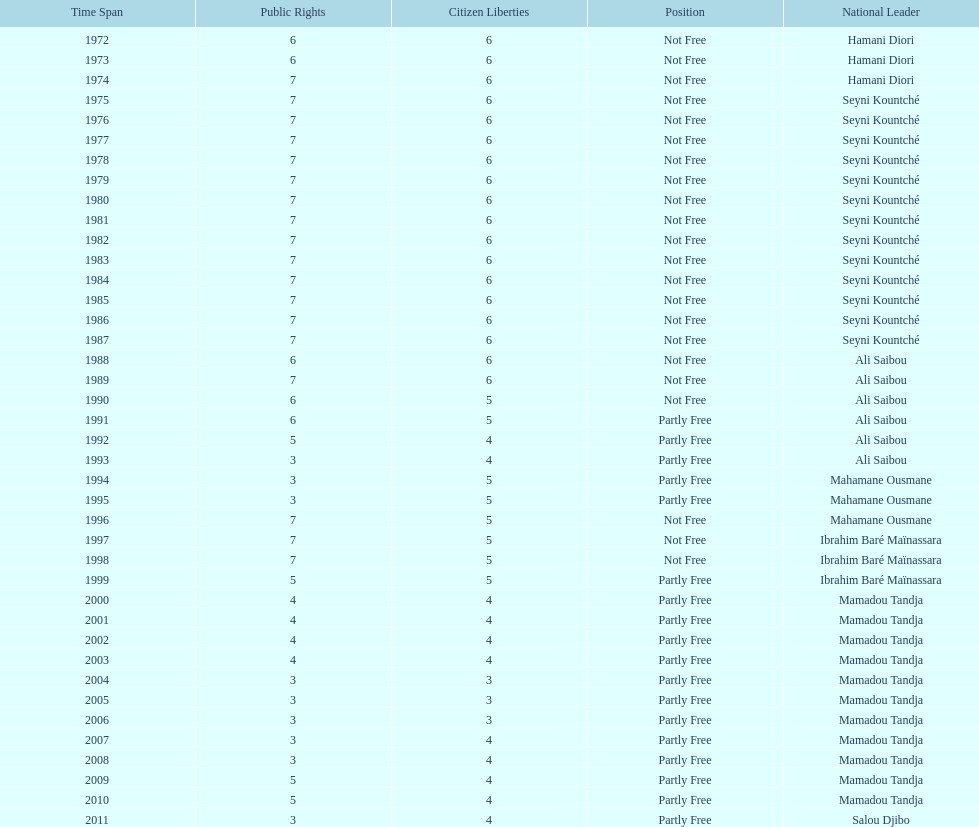What is the number of time seyni kountche has been president? 13. I'm looking to parse the entire table for insights. Could you assist me with that? {'header': ['Time Span', 'Public Rights', 'Citizen Liberties', 'Position', 'National Leader'], 'rows': [['1972', '6', '6', 'Not Free', 'Hamani Diori'], ['1973', '6', '6', 'Not Free', 'Hamani Diori'], ['1974', '7', '6', 'Not Free', 'Hamani Diori'], ['1975', '7', '6', 'Not Free', 'Seyni Kountché'], ['1976', '7', '6', 'Not Free', 'Seyni Kountché'], ['1977', '7', '6', 'Not Free', 'Seyni Kountché'], ['1978', '7', '6', 'Not Free', 'Seyni Kountché'], ['1979', '7', '6', 'Not Free', 'Seyni Kountché'], ['1980', '7', '6', 'Not Free', 'Seyni Kountché'], ['1981', '7', '6', 'Not Free', 'Seyni Kountché'], ['1982', '7', '6', 'Not Free', 'Seyni Kountché'], ['1983', '7', '6', 'Not Free', 'Seyni Kountché'], ['1984', '7', '6', 'Not Free', 'Seyni Kountché'], ['1985', '7', '6', 'Not Free', 'Seyni Kountché'], ['1986', '7', '6', 'Not Free', 'Seyni Kountché'], ['1987', '7', '6', 'Not Free', 'Seyni Kountché'], ['1988', '6', '6', 'Not Free', 'Ali Saibou'], ['1989', '7', '6', 'Not Free', 'Ali Saibou'], ['1990', '6', '5', 'Not Free', 'Ali Saibou'], ['1991', '6', '5', 'Partly Free', 'Ali Saibou'], ['1992', '5', '4', 'Partly Free', 'Ali Saibou'], ['1993', '3', '4', 'Partly Free', 'Ali Saibou'], ['1994', '3', '5', 'Partly Free', 'Mahamane Ousmane'], ['1995', '3', '5', 'Partly Free', 'Mahamane Ousmane'], ['1996', '7', '5', 'Not Free', 'Mahamane Ousmane'], ['1997', '7', '5', 'Not Free', 'Ibrahim Baré Maïnassara'], ['1998', '7', '5', 'Not Free', 'Ibrahim Baré Maïnassara'], ['1999', '5', '5', 'Partly Free', 'Ibrahim Baré Maïnassara'], ['2000', '4', '4', 'Partly Free', 'Mamadou Tandja'], ['2001', '4', '4', 'Partly Free', 'Mamadou Tandja'], ['2002', '4', '4', 'Partly Free', 'Mamadou Tandja'], ['2003', '4', '4', 'Partly Free', 'Mamadou Tandja'], ['2004', '3', '3', 'Partly Free', 'Mamadou Tandja'], ['2005', '3', '3', 'Partly Free', 'Mamadou Tandja'], ['2006', '3', '3', 'Partly Free', 'Mamadou Tandja'], ['2007', '3', '4', 'Partly Free', 'Mamadou Tandja'], ['2008', '3', '4', 'Partly Free', 'Mamadou Tandja'], ['2009', '5', '4', 'Partly Free', 'Mamadou Tandja'], ['2010', '5', '4', 'Partly Free', 'Mamadou Tandja'], ['2011', '3', '4', 'Partly Free', 'Salou Djibo']]} 